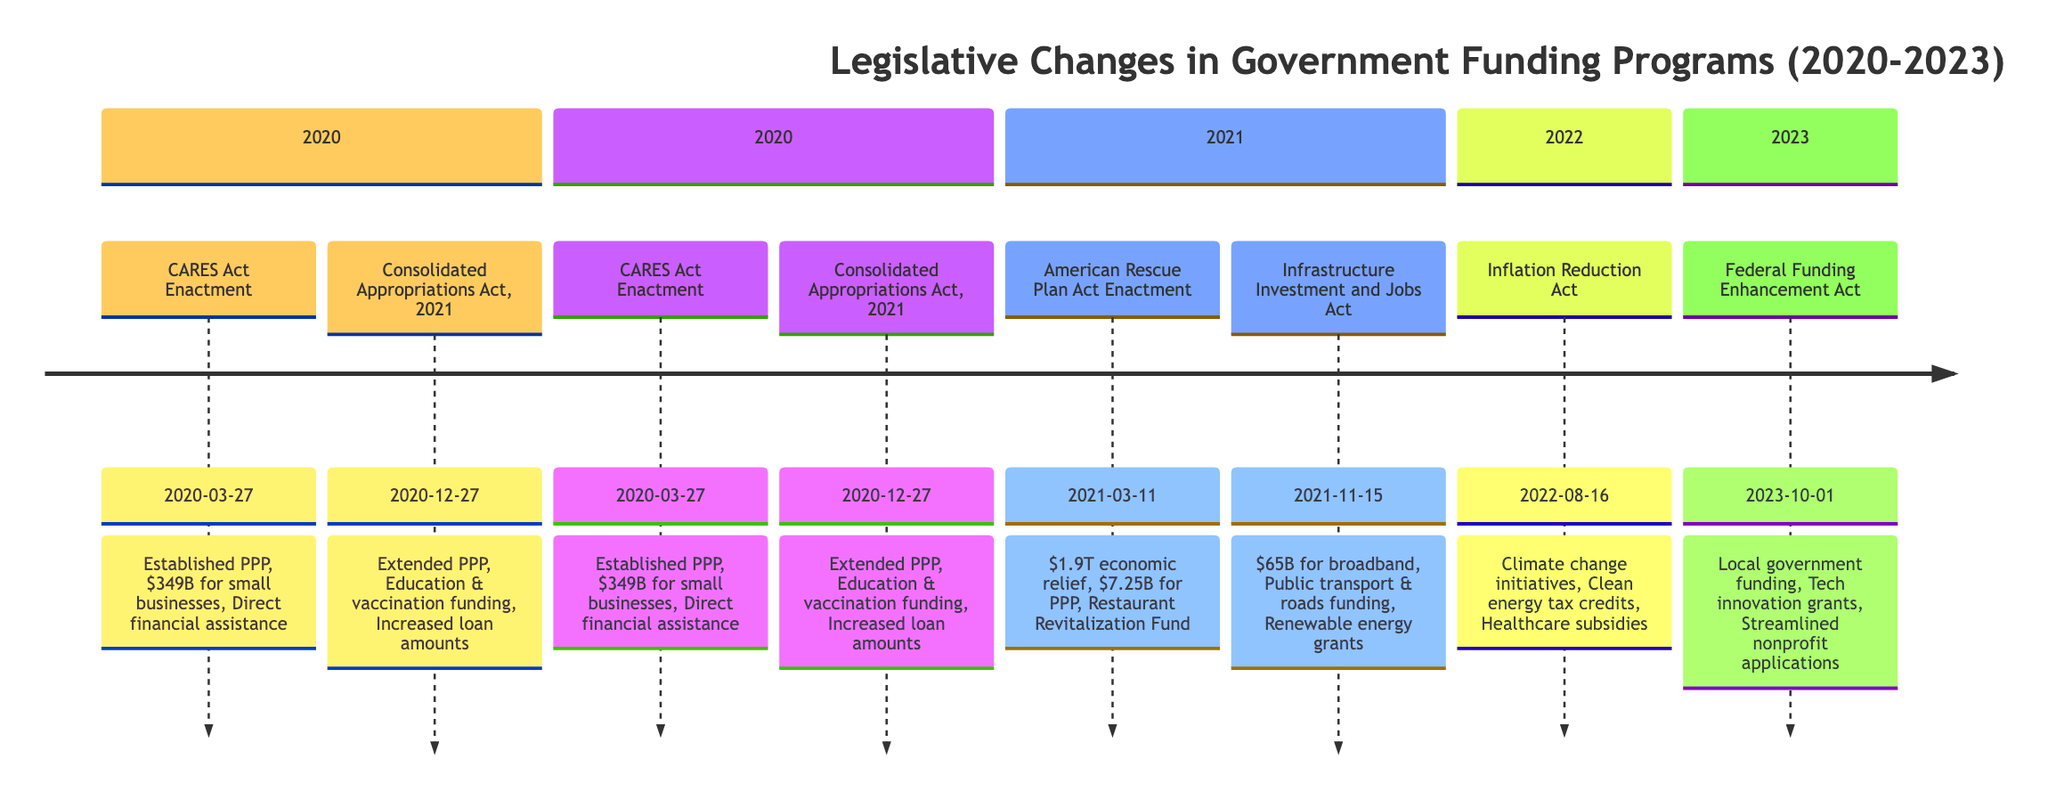What was the date of the CARES Act Enactment? The diagram shows that the CARES Act was enacted on March 27, 2020. Therefore, the date of the event is directly taken from the timeline.
Answer: 2020-03-27 What funding amount was established by the CARES Act for small businesses? The diagram indicates that the CARES Act provided $349 billion in loans for small businesses, which is highlighted in the key provisions related to this event.
Answer: $349 billion How many main legislative changes occurred in 2021? By reviewing the timeline, there are three events listed for 2021: the American Rescue Plan Act, and the Infrastructure Investment and Jobs Act. The number of events is counted directly from the timeline.
Answer: 2 What is the total amount allocated in the American Rescue Plan for additional PPP funding? The timeline specifies that the American Rescue Plan Act included $7.25 billion for additional PPP funding, which is directly stated in the key provisions of the event.
Answer: $7.25 billion Which act enacted on October 1, 2023, focuses on enhancing grant opportunities? The timeline shows that the Federal Funding Enhancement Act, enacted on October 1, 2023, enhanced grant opportunities for technology innovations, which is stated in the key provisions.
Answer: Federal Funding Enhancement Act Which act provided funding for broadband expansion? The Infrastructure Investment and Jobs Act, enacted on November 15, 2021, allocated $65 billion for broadband expansion, as detailed in the key provisions associated with this act on the timeline.
Answer: Infrastructure Investment and Jobs Act What main provision is included in the Inflation Reduction Act? The Inflation Reduction Act includes several provisions, one of which is funding for climate change initiatives. This detail is specifically mentioned in the key provisions derived from the timeline.
Answer: Climate change initiatives Which event took place last among the listed legislative changes? The last event in the timeline is the Federal Funding Enhancement Act on October 1, 2023, which is identified by looking at the order of events from top to bottom in the visual representation.
Answer: Federal Funding Enhancement Act What did the Consolidated Appropriations Act enable regarding loan amounts? The diagram states that the Consolidated Appropriations Act, enacted on December 27, 2020, increased the maximum loan amounts for businesses, which is one of its key provisions.
Answer: Increased loan amounts 